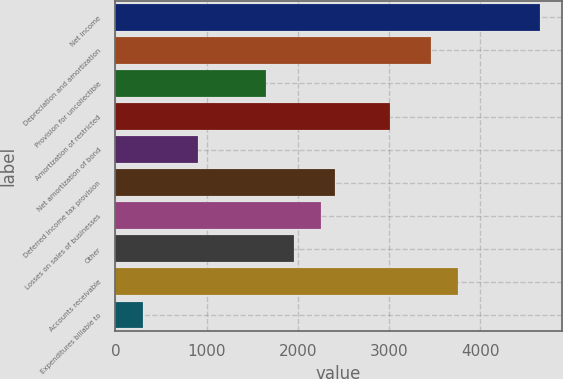Convert chart to OTSL. <chart><loc_0><loc_0><loc_500><loc_500><bar_chart><fcel>Net income<fcel>Depreciation and amortization<fcel>Provision for uncollectible<fcel>Amortization of restricted<fcel>Net amortization of bond<fcel>Deferred income tax provision<fcel>Losses on sales of businesses<fcel>Other<fcel>Accounts receivable<fcel>Expenditures billable to<nl><fcel>4657.52<fcel>3455.76<fcel>1653.12<fcel>3005.1<fcel>902.02<fcel>2404.22<fcel>2254<fcel>1953.56<fcel>3756.2<fcel>301.14<nl></chart> 